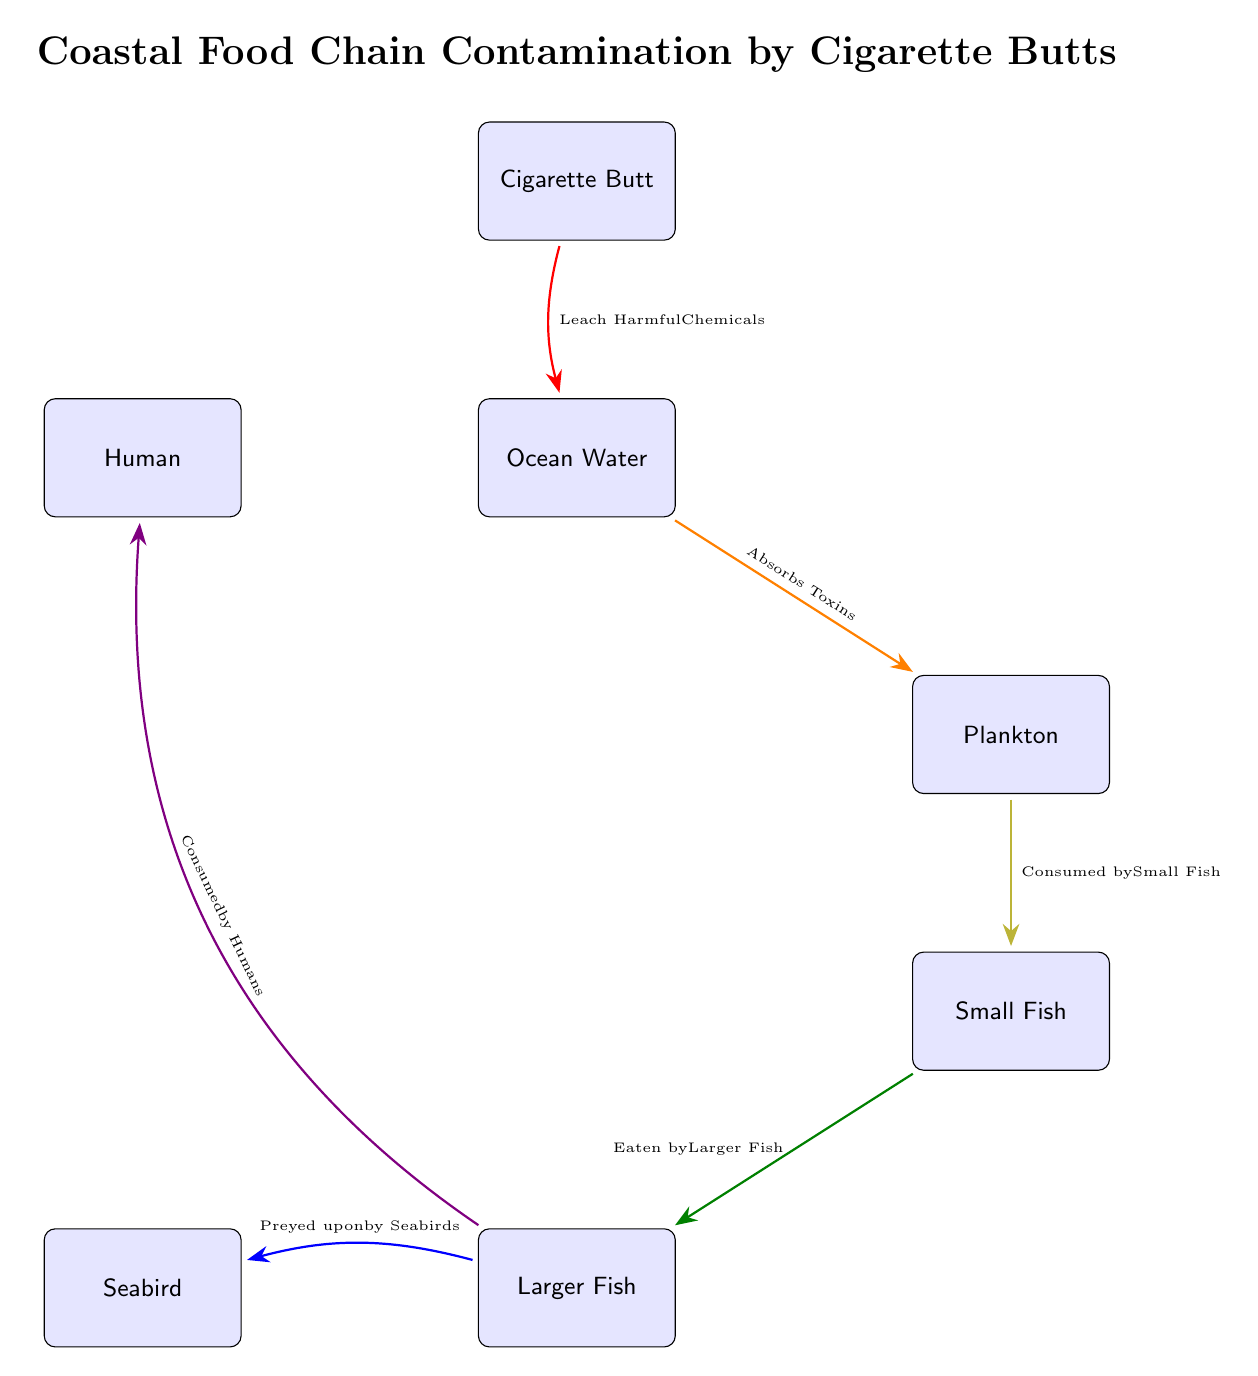What contaminates ocean water? The diagram indicates that cigarette butts leach harmful chemicals into ocean water. Therefore, the source of contamination in the ocean water is the cigarette butt itself.
Answer: Cigarette Butt How many nodes are in the diagram? The diagram consists of six nodes: Cigarette Butt, Ocean Water, Plankton, Small Fish, Larger Fish, and Seabird, along with one additional node representing Humans. Therefore, the total number of nodes is seven.
Answer: 7 What is absorbed by plankton? According to the diagram, ocean water absorbs toxins, which then affects plankton. Hence, the substance absorbed by plankton is toxins derived from ocean water.
Answer: Toxins What do larger fish eat? The diagram shows that larger fish are indicated to eat small fish. Therefore, the food source for larger fish is small fish.
Answer: Small Fish Who preys upon larger fish? The connection in the diagram shows that seabirds prey upon larger fish. Therefore, the predator of larger fish is seabirds.
Answer: Seabird How do humans get exposed to the contaminants? The arrows in the diagram indicate that larger fish are consumed by humans, which means humans may be exposed to contaminants after eating larger fish.
Answer: Consumed by Humans Which node shows the first step of contamination? The first step of contamination in the diagram is represented by the Cigarette Butt, as it is the source from which harmful chemicals begin to leach into the environment.
Answer: Cigarette Butt What is the sequential flow of contamination from cigarette butt to seabird? The flow begins with the Cigarette Butt leaching harmful chemicals into Ocean Water, which absorbs toxins and is consumed by Plankton. Then, the Plankton is eaten by Small Fish, which are in turn consumed by Larger Fish. Finally, the Larger Fish are preyed upon by Seabirds, completing the cycle of contamination.
Answer: Cigarette Butt -> Ocean Water -> Plankton -> Small Fish -> Larger Fish -> Seabird 